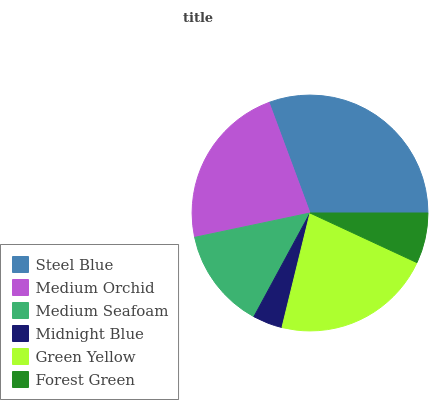Is Midnight Blue the minimum?
Answer yes or no. Yes. Is Steel Blue the maximum?
Answer yes or no. Yes. Is Medium Orchid the minimum?
Answer yes or no. No. Is Medium Orchid the maximum?
Answer yes or no. No. Is Steel Blue greater than Medium Orchid?
Answer yes or no. Yes. Is Medium Orchid less than Steel Blue?
Answer yes or no. Yes. Is Medium Orchid greater than Steel Blue?
Answer yes or no. No. Is Steel Blue less than Medium Orchid?
Answer yes or no. No. Is Green Yellow the high median?
Answer yes or no. Yes. Is Medium Seafoam the low median?
Answer yes or no. Yes. Is Steel Blue the high median?
Answer yes or no. No. Is Midnight Blue the low median?
Answer yes or no. No. 